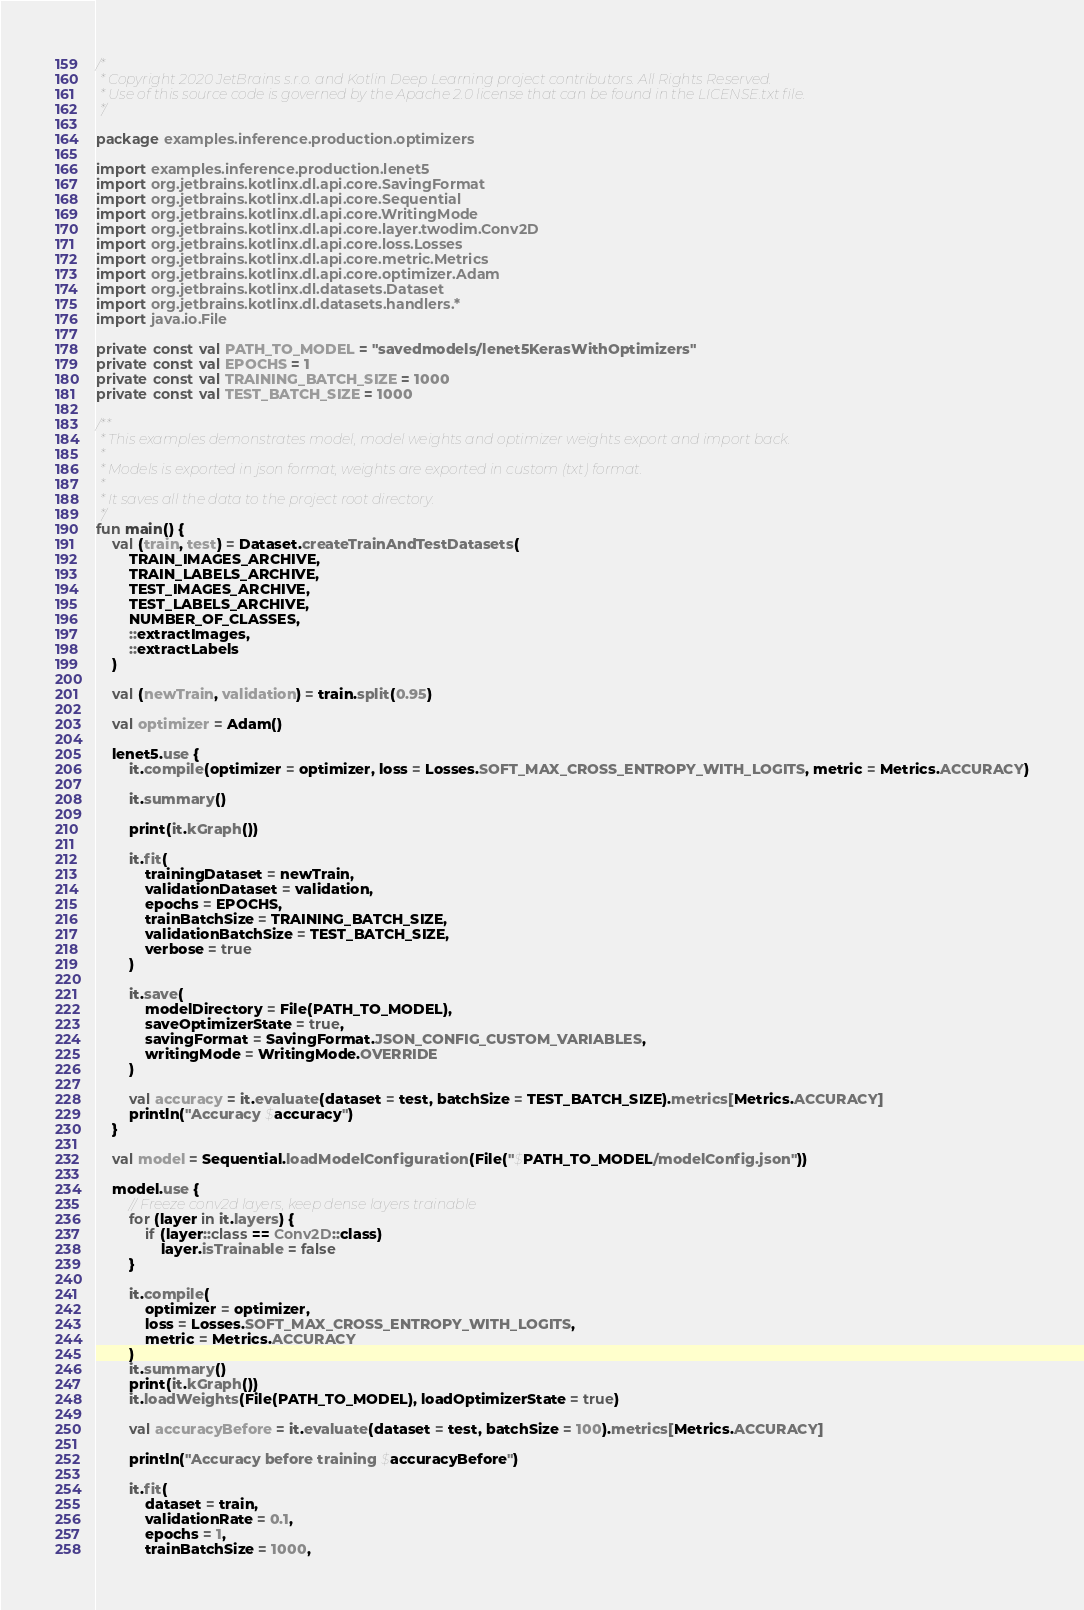Convert code to text. <code><loc_0><loc_0><loc_500><loc_500><_Kotlin_>/*
 * Copyright 2020 JetBrains s.r.o. and Kotlin Deep Learning project contributors. All Rights Reserved.
 * Use of this source code is governed by the Apache 2.0 license that can be found in the LICENSE.txt file.
 */

package examples.inference.production.optimizers

import examples.inference.production.lenet5
import org.jetbrains.kotlinx.dl.api.core.SavingFormat
import org.jetbrains.kotlinx.dl.api.core.Sequential
import org.jetbrains.kotlinx.dl.api.core.WritingMode
import org.jetbrains.kotlinx.dl.api.core.layer.twodim.Conv2D
import org.jetbrains.kotlinx.dl.api.core.loss.Losses
import org.jetbrains.kotlinx.dl.api.core.metric.Metrics
import org.jetbrains.kotlinx.dl.api.core.optimizer.Adam
import org.jetbrains.kotlinx.dl.datasets.Dataset
import org.jetbrains.kotlinx.dl.datasets.handlers.*
import java.io.File

private const val PATH_TO_MODEL = "savedmodels/lenet5KerasWithOptimizers"
private const val EPOCHS = 1
private const val TRAINING_BATCH_SIZE = 1000
private const val TEST_BATCH_SIZE = 1000

/**
 * This examples demonstrates model, model weights and optimizer weights export and import back.
 *
 * Models is exported in json format, weights are exported in custom (txt) format.
 *
 * It saves all the data to the project root directory.
 */
fun main() {
    val (train, test) = Dataset.createTrainAndTestDatasets(
        TRAIN_IMAGES_ARCHIVE,
        TRAIN_LABELS_ARCHIVE,
        TEST_IMAGES_ARCHIVE,
        TEST_LABELS_ARCHIVE,
        NUMBER_OF_CLASSES,
        ::extractImages,
        ::extractLabels
    )

    val (newTrain, validation) = train.split(0.95)

    val optimizer = Adam()

    lenet5.use {
        it.compile(optimizer = optimizer, loss = Losses.SOFT_MAX_CROSS_ENTROPY_WITH_LOGITS, metric = Metrics.ACCURACY)

        it.summary()

        print(it.kGraph())

        it.fit(
            trainingDataset = newTrain,
            validationDataset = validation,
            epochs = EPOCHS,
            trainBatchSize = TRAINING_BATCH_SIZE,
            validationBatchSize = TEST_BATCH_SIZE,
            verbose = true
        )

        it.save(
            modelDirectory = File(PATH_TO_MODEL),
            saveOptimizerState = true,
            savingFormat = SavingFormat.JSON_CONFIG_CUSTOM_VARIABLES,
            writingMode = WritingMode.OVERRIDE
        )

        val accuracy = it.evaluate(dataset = test, batchSize = TEST_BATCH_SIZE).metrics[Metrics.ACCURACY]
        println("Accuracy $accuracy")
    }

    val model = Sequential.loadModelConfiguration(File("$PATH_TO_MODEL/modelConfig.json"))

    model.use {
        // Freeze conv2d layers, keep dense layers trainable
        for (layer in it.layers) {
            if (layer::class == Conv2D::class)
                layer.isTrainable = false
        }

        it.compile(
            optimizer = optimizer,
            loss = Losses.SOFT_MAX_CROSS_ENTROPY_WITH_LOGITS,
            metric = Metrics.ACCURACY
        )
        it.summary()
        print(it.kGraph())
        it.loadWeights(File(PATH_TO_MODEL), loadOptimizerState = true)

        val accuracyBefore = it.evaluate(dataset = test, batchSize = 100).metrics[Metrics.ACCURACY]

        println("Accuracy before training $accuracyBefore")

        it.fit(
            dataset = train,
            validationRate = 0.1,
            epochs = 1,
            trainBatchSize = 1000,</code> 